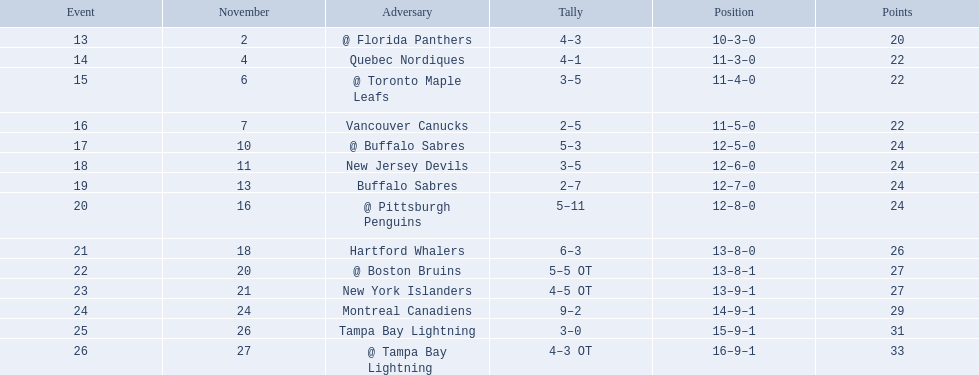What are the teams in the atlantic division? Quebec Nordiques, Vancouver Canucks, New Jersey Devils, Buffalo Sabres, Hartford Whalers, New York Islanders, Montreal Canadiens, Tampa Bay Lightning. Which of those scored fewer points than the philadelphia flyers? Tampa Bay Lightning. 